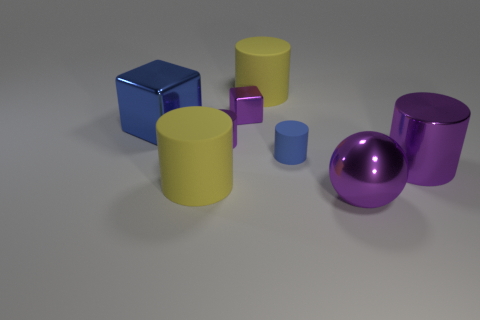There is a sphere that is made of the same material as the big blue cube; what size is it?
Your answer should be very brief. Large. How many shiny things are either red spheres or tiny blue cylinders?
Your answer should be very brief. 0. How big is the sphere?
Offer a very short reply. Large. Do the purple metallic cube and the blue cylinder have the same size?
Provide a short and direct response. Yes. What material is the purple cylinder that is to the left of the purple shiny sphere?
Provide a short and direct response. Metal. There is another small thing that is the same shape as the blue rubber thing; what material is it?
Offer a terse response. Metal. There is a shiny cylinder that is in front of the blue matte cylinder; is there a tiny block to the left of it?
Your answer should be compact. Yes. Does the small matte thing have the same shape as the big blue metallic thing?
Make the answer very short. No. There is a blue thing that is made of the same material as the small block; what is its shape?
Give a very brief answer. Cube. Is the size of the blue object that is right of the large blue thing the same as the shiny cylinder on the left side of the metal sphere?
Ensure brevity in your answer.  Yes. 